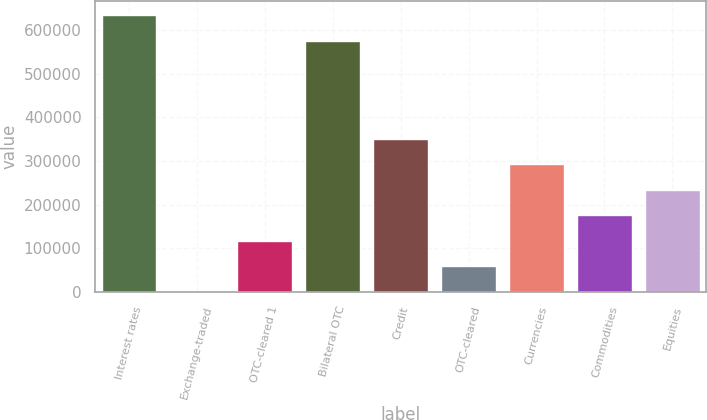Convert chart. <chart><loc_0><loc_0><loc_500><loc_500><bar_chart><fcel>Interest rates<fcel>Exchange-traded<fcel>OTC-cleared 1<fcel>Bilateral OTC<fcel>Credit<fcel>OTC-cleared<fcel>Currencies<fcel>Commodities<fcel>Equities<nl><fcel>634144<fcel>47<fcel>116954<fcel>575690<fcel>350769<fcel>58500.7<fcel>292316<fcel>175408<fcel>233862<nl></chart> 